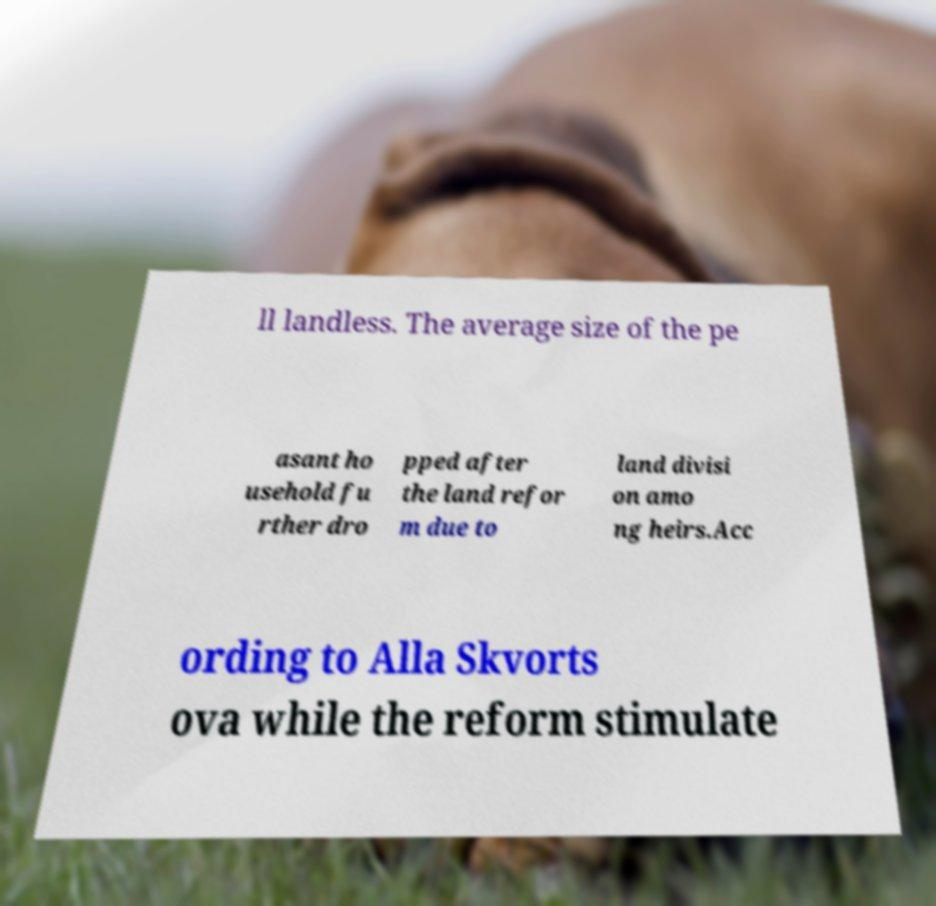Please read and relay the text visible in this image. What does it say? ll landless. The average size of the pe asant ho usehold fu rther dro pped after the land refor m due to land divisi on amo ng heirs.Acc ording to Alla Skvorts ova while the reform stimulate 